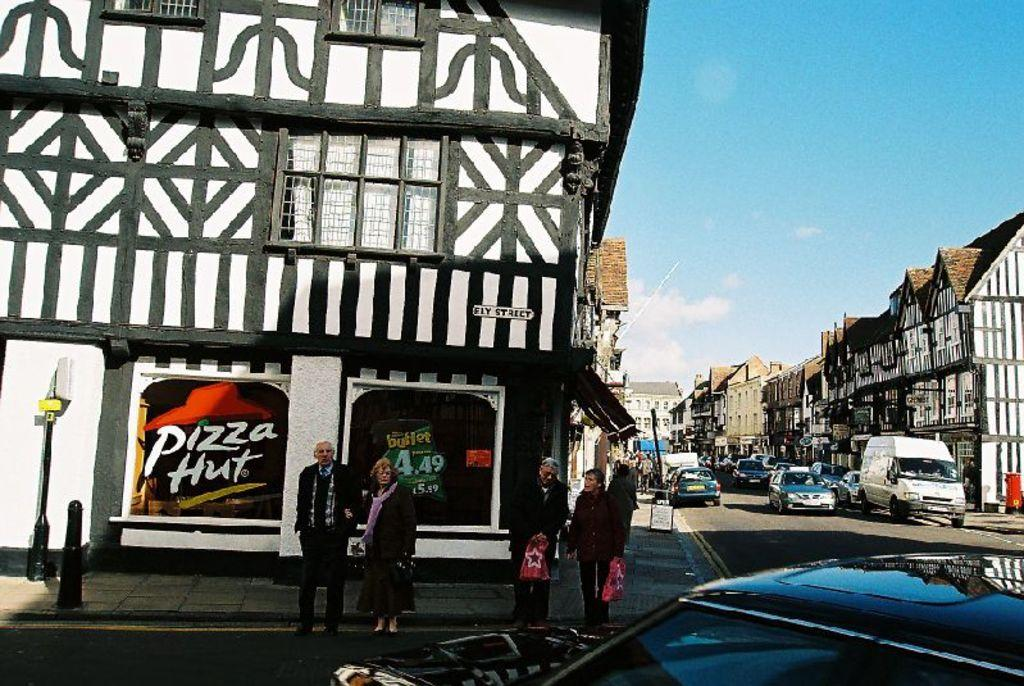What can be seen on the road in the image? There are vehicles on the road in the image. Who or what can be seen in the image besides the vehicles? There are people visible in the image. What is present on both sides of the road in the image? There are buildings on the left and right sides of the image. What is visible in the sky in the background of the image? There are clouds in the sky in the background of the image. What scientific discovery is being made by the dog in the image? There is no dog present in the image, and therefore no scientific discovery can be observed. What type of trade is being conducted by the people in the image? The image does not provide information about any trade being conducted by the people; they are simply visible in the image. 